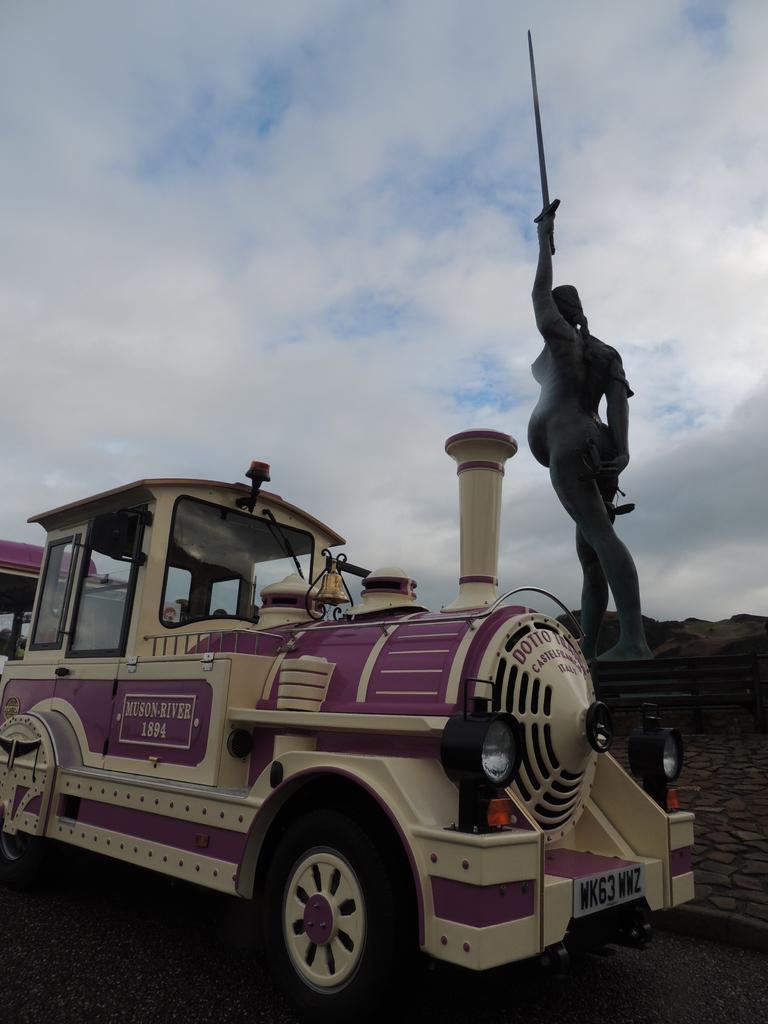How would you summarize this image in a sentence or two? In this picture we can observe a vehicle which is looking like a train engine. This vehicle is in cream and purple color. We can observe a statue on the right side. In the background there are hills and a sky with some clouds. 